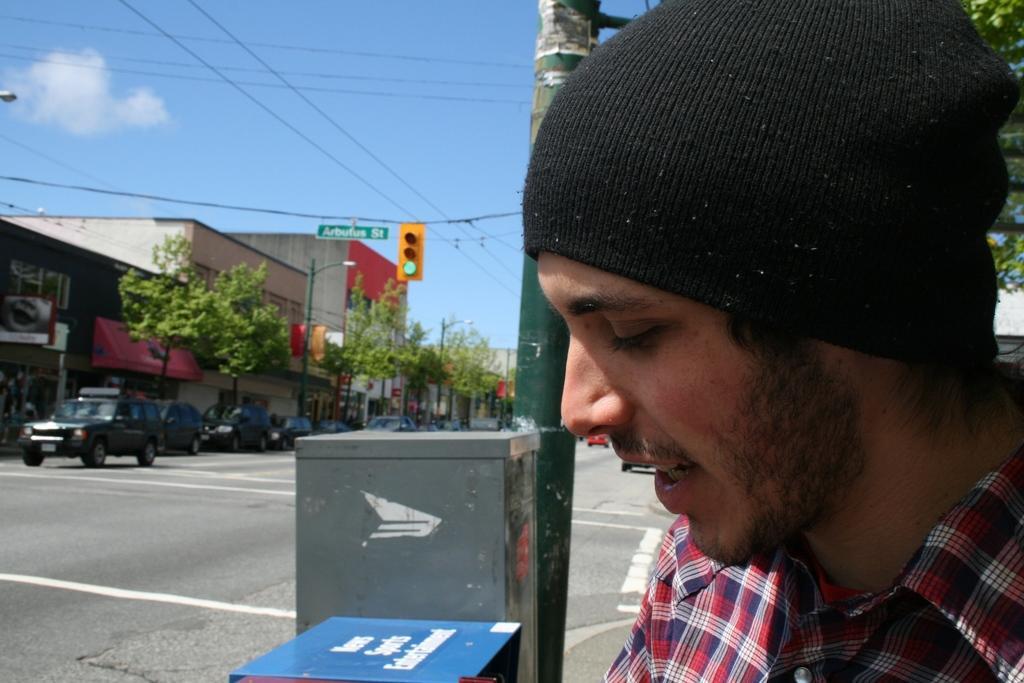Can you describe this image briefly? In this image we can see a man wearing a beanie. In the background we can see buildings, trees, traffic lights, street poles, street lights, electric cables and motor vehicles on the road. 